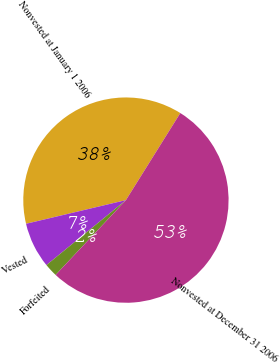<chart> <loc_0><loc_0><loc_500><loc_500><pie_chart><fcel>Nonvested at January 1 2006<fcel>Vested<fcel>Forfeited<fcel>Nonvested at December 31 2006<nl><fcel>37.59%<fcel>7.2%<fcel>2.09%<fcel>53.12%<nl></chart> 